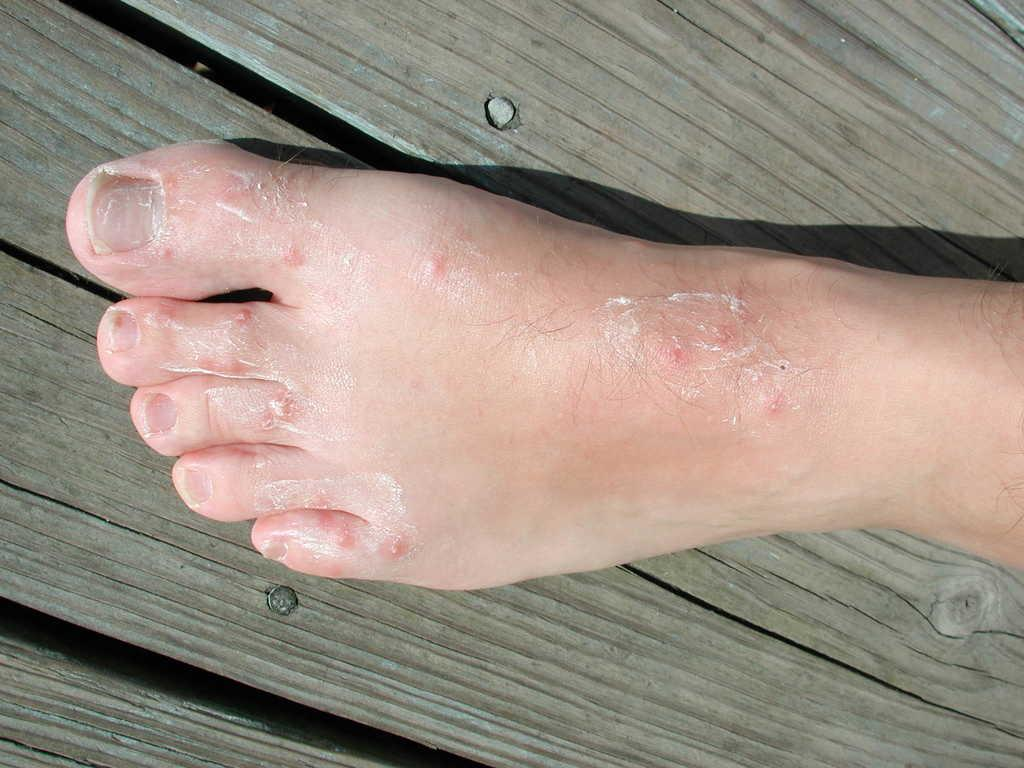What type of surface is visible in the image? There is a wooden surface in the image. What is on the wooden surface? A person's foot is on the wooden surface. Can you describe the condition of the foot? The foot has pimples. What has been applied to the foot? Cream has been applied to the foot. What type of clothing is the scarecrow wearing in the image? There is no scarecrow present in the image. How many kittens are sitting on the wooden surface in the image? There are no kittens present in the image. 